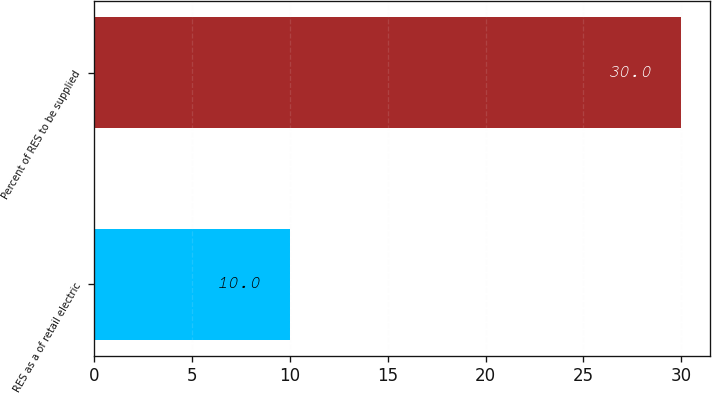Convert chart to OTSL. <chart><loc_0><loc_0><loc_500><loc_500><bar_chart><fcel>RES as a of retail electric<fcel>Percent of RES to be supplied<nl><fcel>10<fcel>30<nl></chart> 